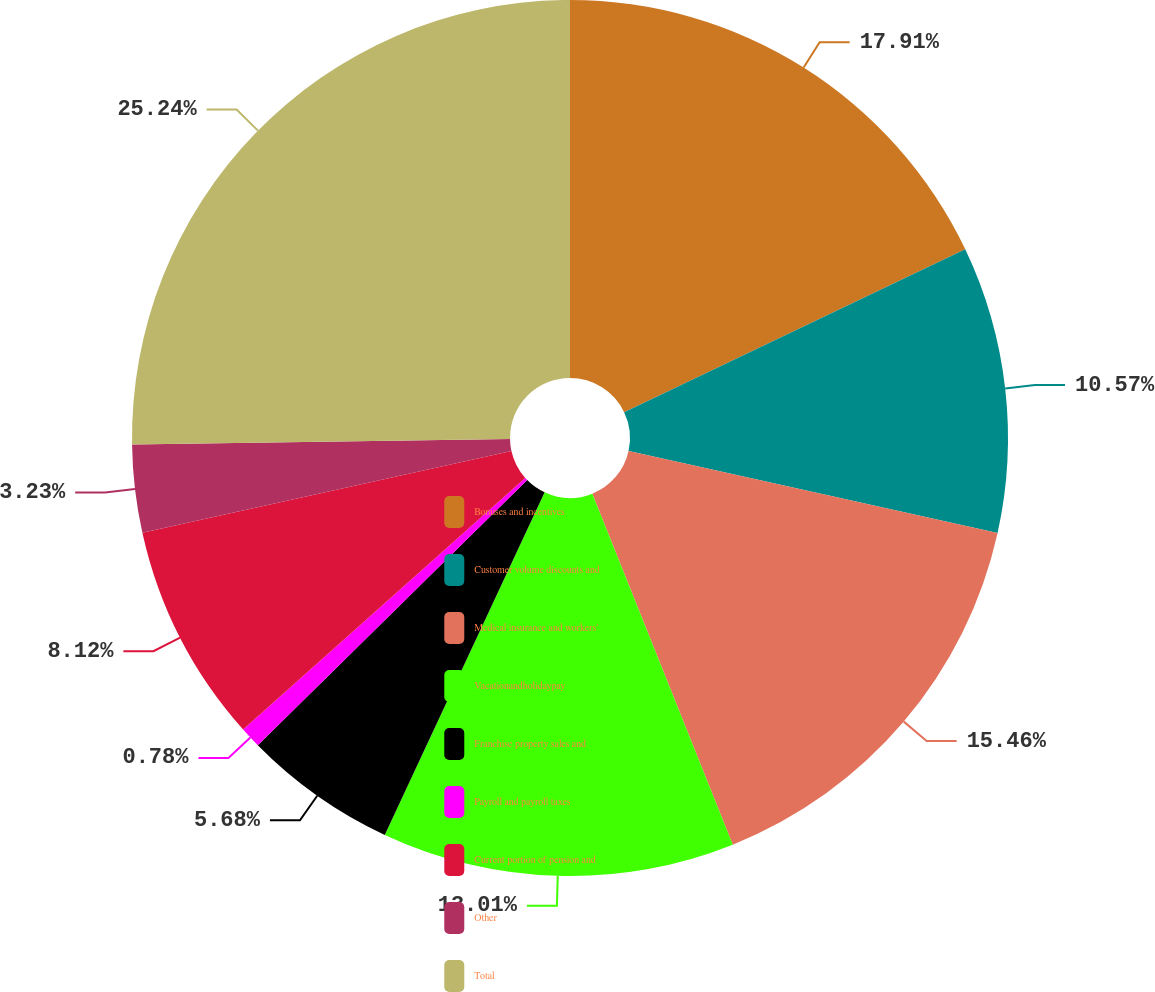Convert chart to OTSL. <chart><loc_0><loc_0><loc_500><loc_500><pie_chart><fcel>Bonuses and incentives<fcel>Customer volume discounts and<fcel>Medical insurance and workers'<fcel>Vacationandholidaypay<fcel>Franchise property sales and<fcel>Payroll and payroll taxes<fcel>Current portion of pension and<fcel>Other<fcel>Total<nl><fcel>17.91%<fcel>10.57%<fcel>15.46%<fcel>13.01%<fcel>5.68%<fcel>0.78%<fcel>8.12%<fcel>3.23%<fcel>25.24%<nl></chart> 